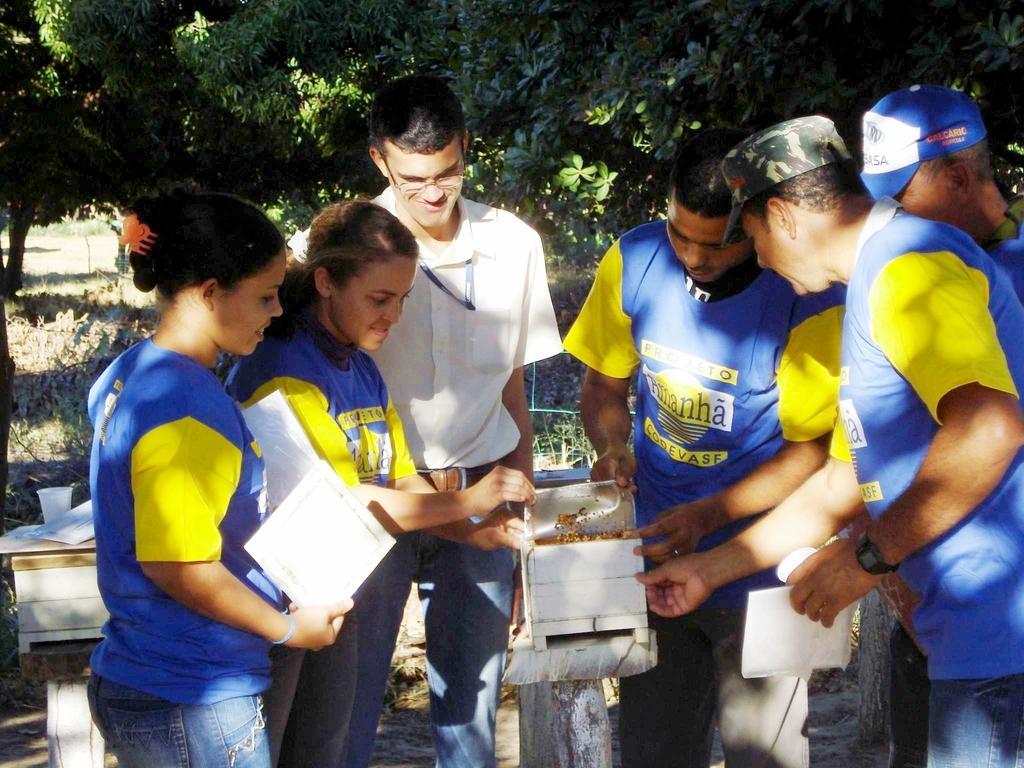Could you give a brief overview of what you see in this image? In this image there are people standing and few are holding a box and few are holding papers in their hands, in the background there are trees. 